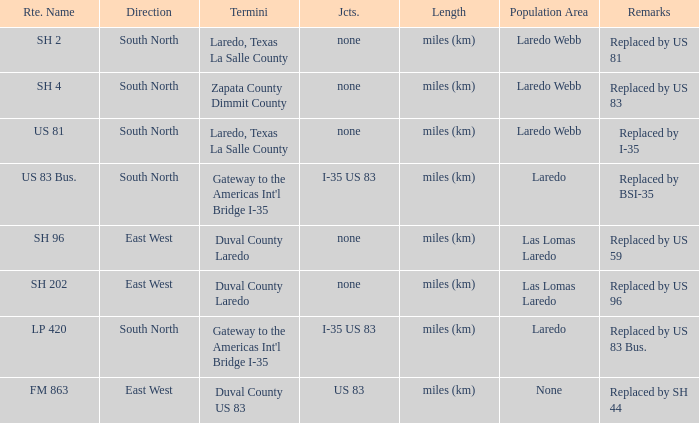Which routes have  "replaced by US 81" listed in their remarks section? SH 2. 